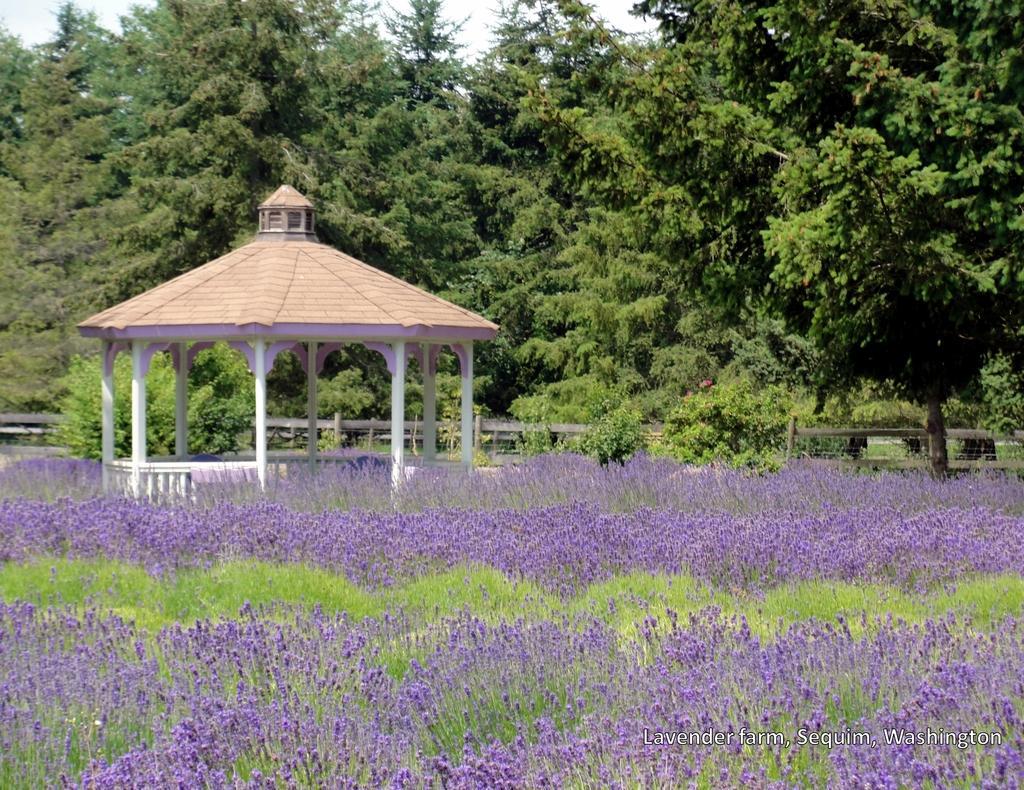Could you give a brief overview of what you see in this image? In this image at the bottom there are some plants and flowers and in the center there is house, in the background there is a fence and some trees. 